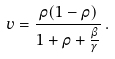Convert formula to latex. <formula><loc_0><loc_0><loc_500><loc_500>v = \frac { \rho ( 1 - \rho ) } { 1 + \rho + \frac { \beta } { \gamma } } \, .</formula> 